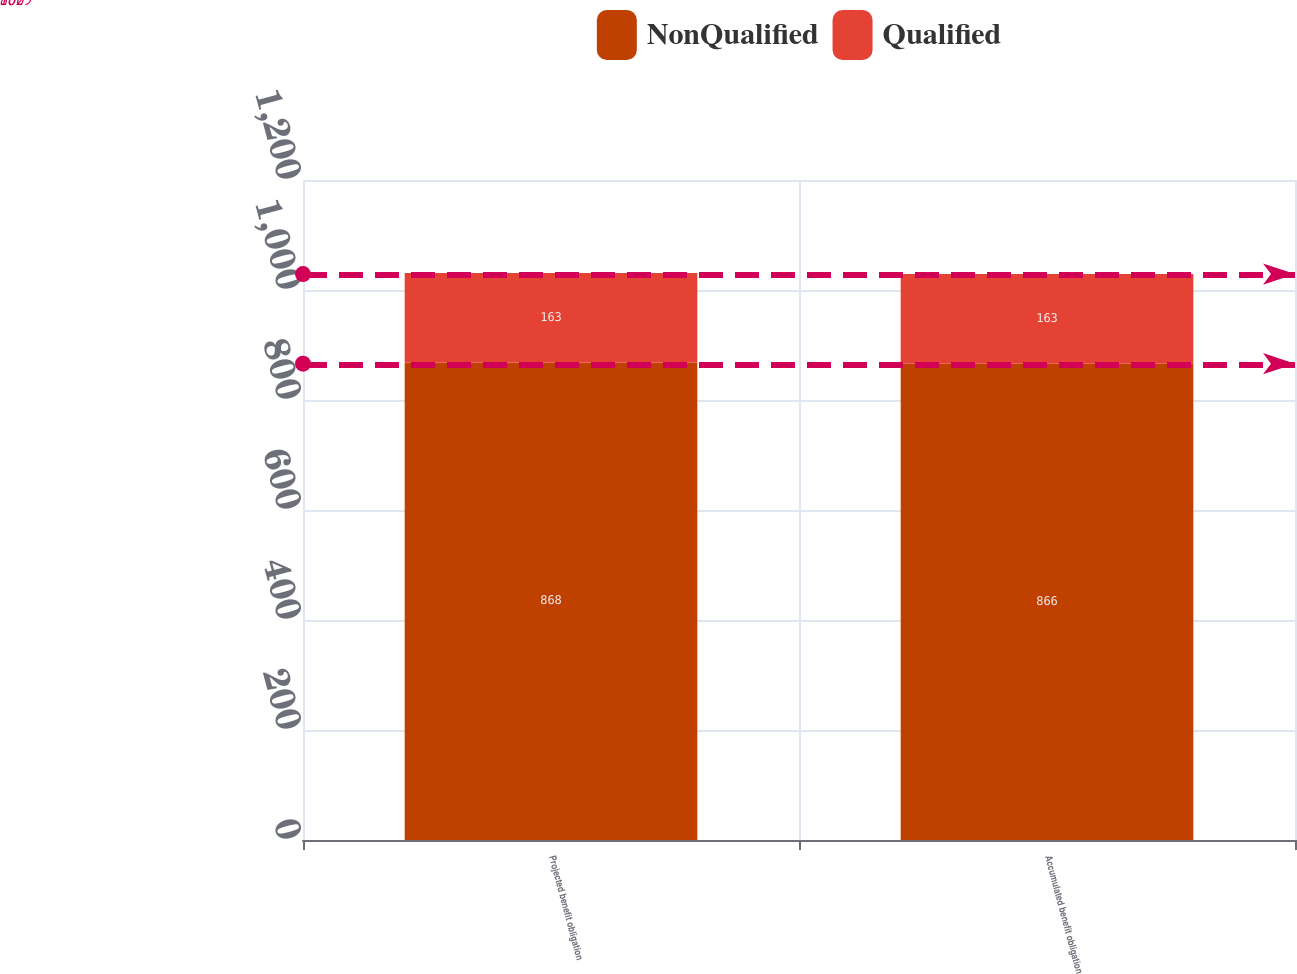Convert chart. <chart><loc_0><loc_0><loc_500><loc_500><stacked_bar_chart><ecel><fcel>Projected benefit obligation<fcel>Accumulated benefit obligation<nl><fcel>NonQualified<fcel>868<fcel>866<nl><fcel>Qualified<fcel>163<fcel>163<nl></chart> 